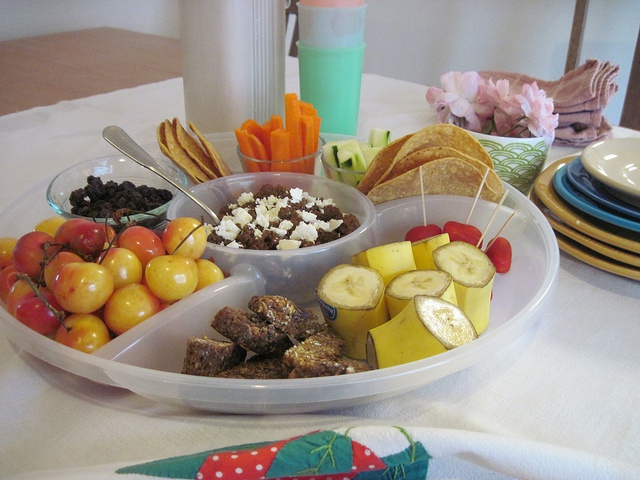Describe the objects in this image and their specific colors. I can see dining table in darkgray, lightgray, gray, and tan tones, dining table in gray, lightgray, and darkgray tones, bowl in gray, darkgray, and maroon tones, bowl in gray, darkgray, and black tones, and potted plant in gray, darkgray, lavender, and pink tones in this image. 